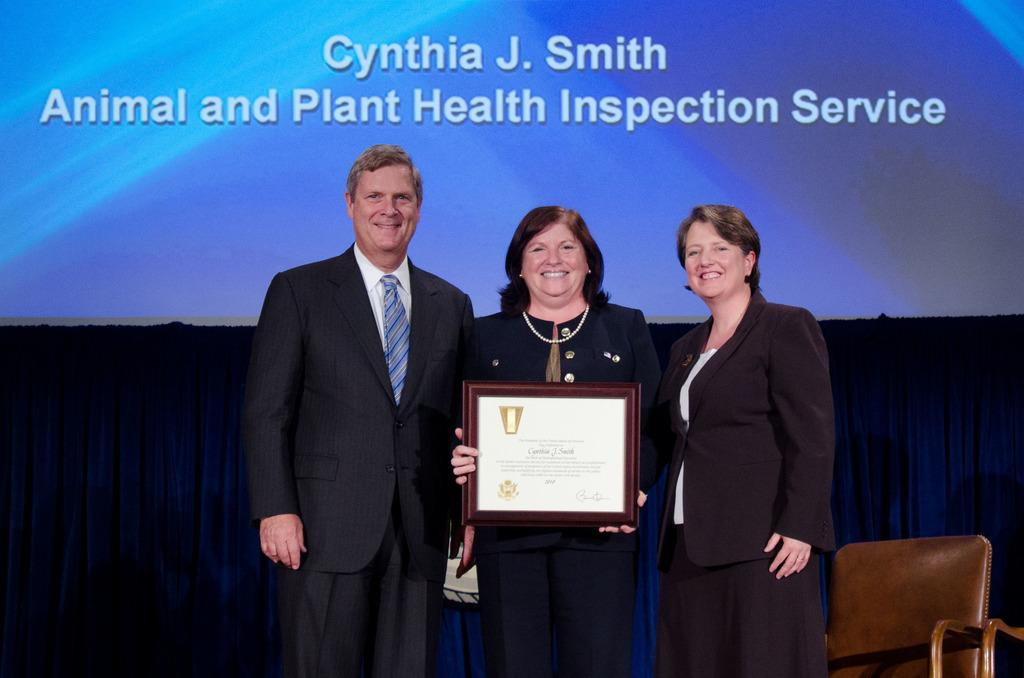How many people are standing in the image? There are three persons standing in the image. What is the middle person holding? The middle person is holding a momentum. What can be seen in the background of the image? There is a curtain and a wall with writing in the background. What type of furniture is on the right side of the image? There is a chair on the right side of the image. What type of canvas can be seen in the image? There is no canvas present in the image. Are there any boats visible in the image? There are no boats visible in the image. 